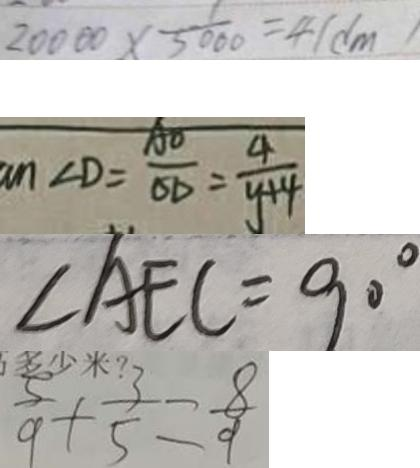Convert formula to latex. <formula><loc_0><loc_0><loc_500><loc_500>2 0 0 0 0 \times \frac { 1 } { 5 0 0 0 } = 4 ( d m ) 
 a n \angle D = \frac { A O } { O D } = \frac { 4 } { y + 4 } 
 \angle A E C = 9 0 ^ { \circ } 
 \frac { 5 } { 9 } + \frac { 3 } { 5 } = \frac { 8 } { 9 }</formula> 